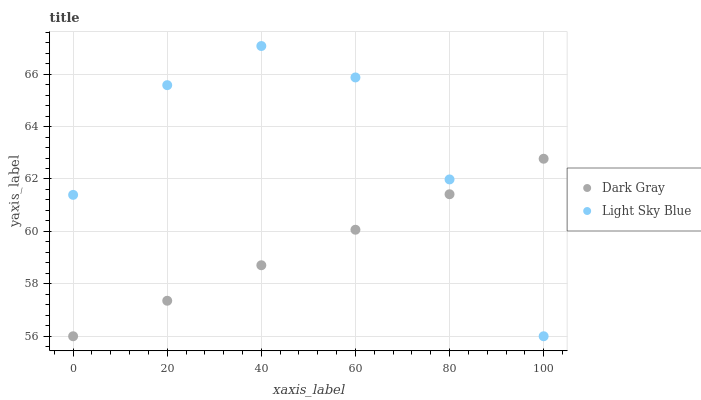Does Dark Gray have the minimum area under the curve?
Answer yes or no. Yes. Does Light Sky Blue have the maximum area under the curve?
Answer yes or no. Yes. Does Light Sky Blue have the minimum area under the curve?
Answer yes or no. No. Is Dark Gray the smoothest?
Answer yes or no. Yes. Is Light Sky Blue the roughest?
Answer yes or no. Yes. Is Light Sky Blue the smoothest?
Answer yes or no. No. Does Dark Gray have the lowest value?
Answer yes or no. Yes. Does Light Sky Blue have the highest value?
Answer yes or no. Yes. Does Dark Gray intersect Light Sky Blue?
Answer yes or no. Yes. Is Dark Gray less than Light Sky Blue?
Answer yes or no. No. Is Dark Gray greater than Light Sky Blue?
Answer yes or no. No. 